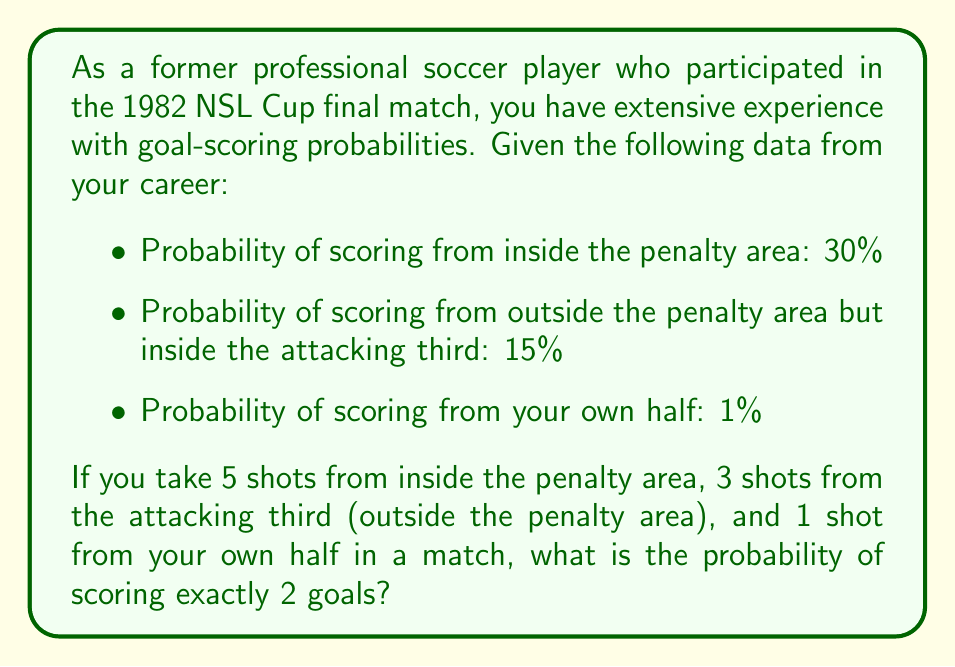Solve this math problem. Let's approach this step-by-step:

1) First, we need to calculate the probability of scoring exactly 2 goals out of 9 shots. This is a binomial probability problem with multiple probabilities.

2) We can use the concept of independent events and the multiplication rule of probability.

3) Let's define the events:
   A: Score from inside the penalty area (5 attempts, p = 0.30)
   B: Score from attacking third outside penalty area (3 attempts, p = 0.15)
   C: Score from own half (1 attempt, p = 0.01)

4) We need to consider all possible combinations of scoring exactly 2 goals. These are:
   - 2 goals from A, 0 from B, 0 from C
   - 1 goal from A, 1 from B, 0 from C
   - 1 goal from A, 0 from B, 1 from C
   - 0 goals from A, 2 from B, 0 from C
   - 0 goals from A, 1 from B, 1 from C

5) Let's calculate each probability:

   P(2A, 0B, 0C) = $\binom{5}{2}(0.30)^2(0.70)^3 \cdot \binom{3}{0}(0.15)^0(0.85)^3 \cdot \binom{1}{0}(0.01)^0(0.99)^1$
                 = $10 \cdot 0.09 \cdot 0.343 \cdot 1 \cdot 0.614 \cdot 1 \cdot 0.99 = 0.0187$

   P(1A, 1B, 0C) = $\binom{5}{1}(0.30)^1(0.70)^4 \cdot \binom{3}{1}(0.15)^1(0.85)^2 \cdot \binom{1}{0}(0.01)^0(0.99)^1$
                 = $5 \cdot 0.30 \cdot 0.240 \cdot 3 \cdot 0.15 \cdot 0.723 \cdot 1 \cdot 0.99 = 0.0139$

   P(1A, 0B, 1C) = $\binom{5}{1}(0.30)^1(0.70)^4 \cdot \binom{3}{0}(0.15)^0(0.85)^3 \cdot \binom{1}{1}(0.01)^1(0.99)^0$
                 = $5 \cdot 0.30 \cdot 0.240 \cdot 1 \cdot 0.614 \cdot 1 \cdot 0.01 = 0.00022$

   P(0A, 2B, 0C) = $\binom{5}{0}(0.30)^0(0.70)^5 \cdot \binom{3}{2}(0.15)^2(0.85)^1 \cdot \binom{1}{0}(0.01)^0(0.99)^1$
                 = $1 \cdot 0.168 \cdot 3 \cdot 0.0225 \cdot 0.85 \cdot 1 \cdot 0.99 = 0.00095$

   P(0A, 1B, 1C) = $\binom{5}{0}(0.30)^0(0.70)^5 \cdot \binom{3}{1}(0.15)^1(0.85)^2 \cdot \binom{1}{1}(0.01)^1(0.99)^0$
                 = $1 \cdot 0.168 \cdot 3 \cdot 0.15 \cdot 0.723 \cdot 1 \cdot 0.01 = 0.000055$

6) The total probability is the sum of all these individual probabilities:

   $P(\text{exactly 2 goals}) = 0.0187 + 0.0139 + 0.00022 + 0.00095 + 0.000055 = 0.03383$
Answer: $0.03383$ or $3.383\%$ 